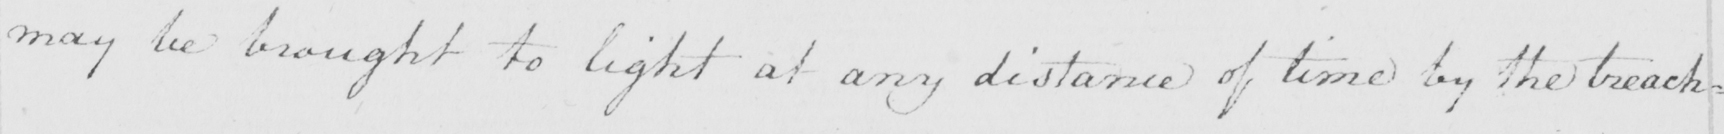Can you read and transcribe this handwriting? may be brought to light at any distance of time by the treach= 